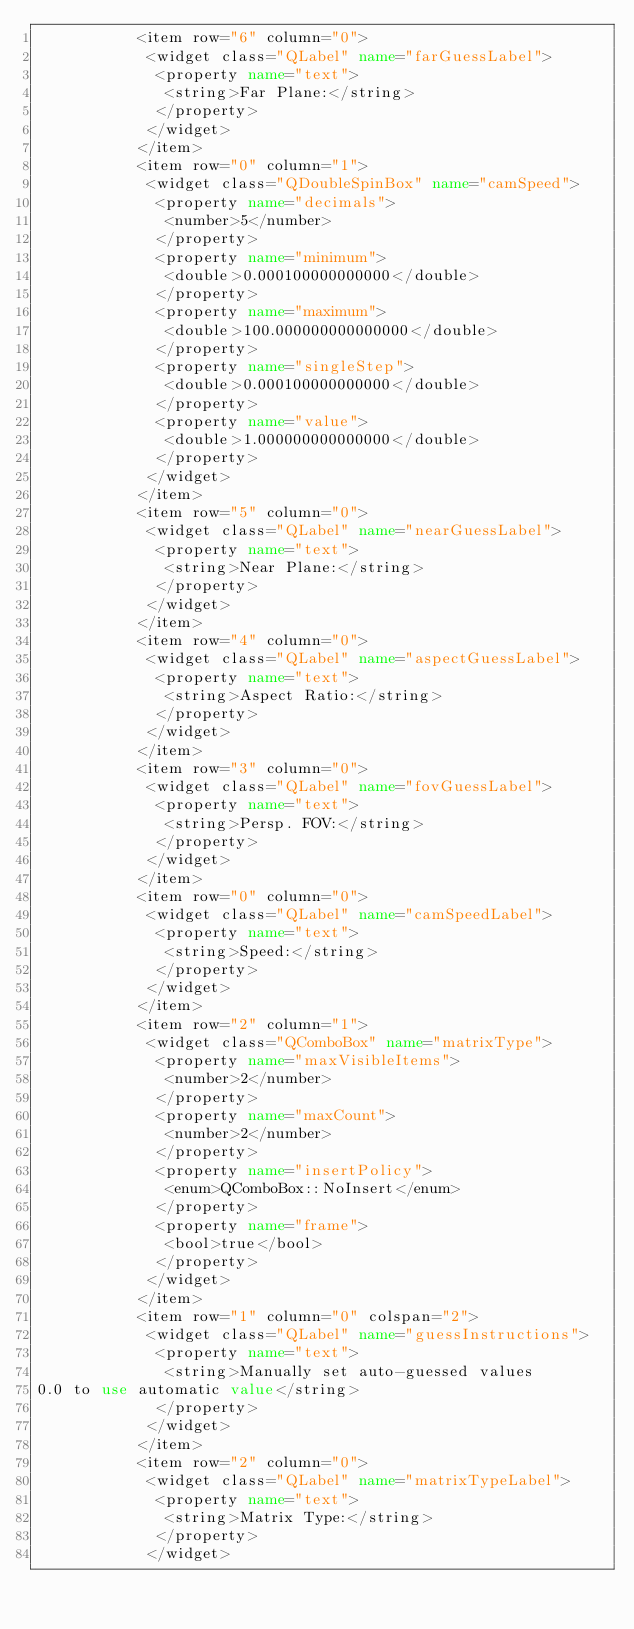<code> <loc_0><loc_0><loc_500><loc_500><_XML_>           <item row="6" column="0">
            <widget class="QLabel" name="farGuessLabel">
             <property name="text">
              <string>Far Plane:</string>
             </property>
            </widget>
           </item>
           <item row="0" column="1">
            <widget class="QDoubleSpinBox" name="camSpeed">
             <property name="decimals">
              <number>5</number>
             </property>
             <property name="minimum">
              <double>0.000100000000000</double>
             </property>
             <property name="maximum">
              <double>100.000000000000000</double>
             </property>
             <property name="singleStep">
              <double>0.000100000000000</double>
             </property>
             <property name="value">
              <double>1.000000000000000</double>
             </property>
            </widget>
           </item>
           <item row="5" column="0">
            <widget class="QLabel" name="nearGuessLabel">
             <property name="text">
              <string>Near Plane:</string>
             </property>
            </widget>
           </item>
           <item row="4" column="0">
            <widget class="QLabel" name="aspectGuessLabel">
             <property name="text">
              <string>Aspect Ratio:</string>
             </property>
            </widget>
           </item>
           <item row="3" column="0">
            <widget class="QLabel" name="fovGuessLabel">
             <property name="text">
              <string>Persp. FOV:</string>
             </property>
            </widget>
           </item>
           <item row="0" column="0">
            <widget class="QLabel" name="camSpeedLabel">
             <property name="text">
              <string>Speed:</string>
             </property>
            </widget>
           </item>
           <item row="2" column="1">
            <widget class="QComboBox" name="matrixType">
             <property name="maxVisibleItems">
              <number>2</number>
             </property>
             <property name="maxCount">
              <number>2</number>
             </property>
             <property name="insertPolicy">
              <enum>QComboBox::NoInsert</enum>
             </property>
             <property name="frame">
              <bool>true</bool>
             </property>
            </widget>
           </item>
           <item row="1" column="0" colspan="2">
            <widget class="QLabel" name="guessInstructions">
             <property name="text">
              <string>Manually set auto-guessed values
0.0 to use automatic value</string>
             </property>
            </widget>
           </item>
           <item row="2" column="0">
            <widget class="QLabel" name="matrixTypeLabel">
             <property name="text">
              <string>Matrix Type:</string>
             </property>
            </widget></code> 